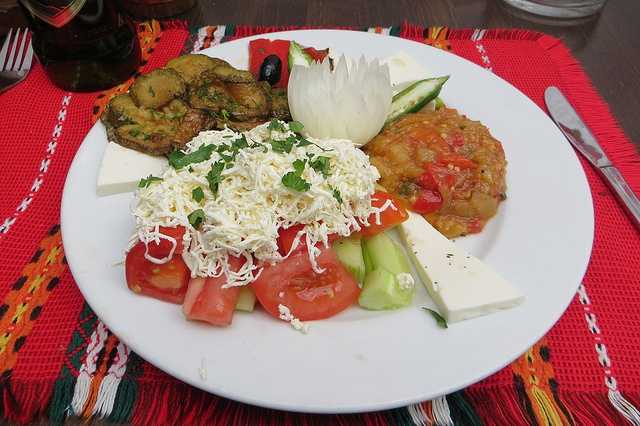Describe the objects in this image and their specific colors. I can see dining table in lightgray, brown, black, and maroon tones, bottle in black, maroon, brown, and olive tones, knife in black, darkgray, brown, maroon, and gray tones, cup in black and gray tones, and fork in black, gray, and maroon tones in this image. 